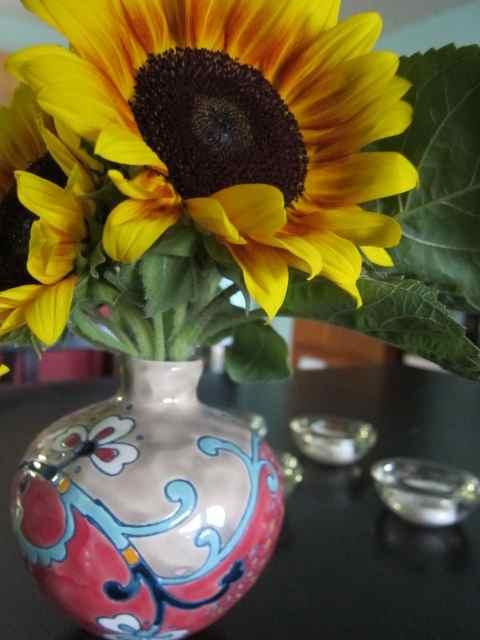What color is the table the vase of flowers is resting on?
Answer briefly. Black. How many petals are on this sunflower?
Give a very brief answer. Many. Is the vase big enough for the flowers?
Answer briefly. Yes. 